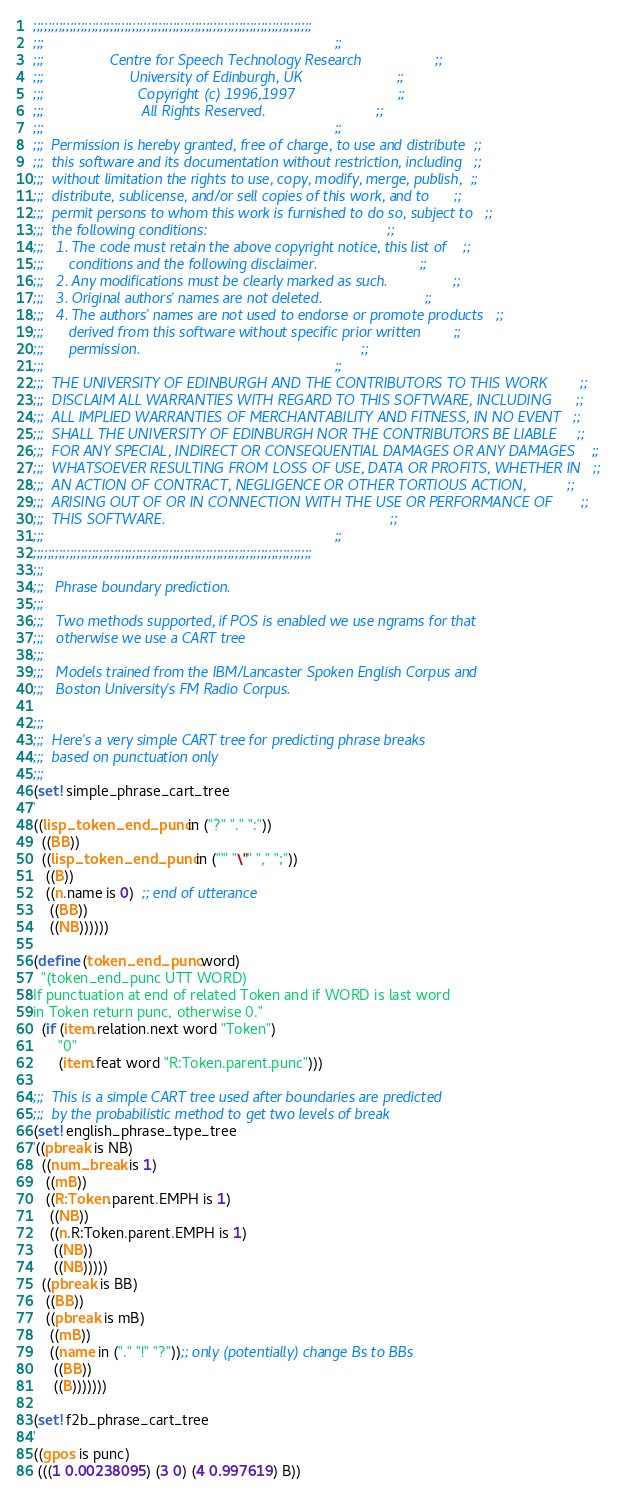<code> <loc_0><loc_0><loc_500><loc_500><_Scheme_>;;;;;;;;;;;;;;;;;;;;;;;;;;;;;;;;;;;;;;;;;;;;;;;;;;;;;;;;;;;;;;;;;;;;;;;;;;;;
;;;                                                                       ;;
;;;                Centre for Speech Technology Research                  ;;
;;;                     University of Edinburgh, UK                       ;;
;;;                       Copyright (c) 1996,1997                         ;;
;;;                        All Rights Reserved.                           ;;
;;;                                                                       ;;
;;;  Permission is hereby granted, free of charge, to use and distribute  ;;
;;;  this software and its documentation without restriction, including   ;;
;;;  without limitation the rights to use, copy, modify, merge, publish,  ;;
;;;  distribute, sublicense, and/or sell copies of this work, and to      ;;
;;;  permit persons to whom this work is furnished to do so, subject to   ;;
;;;  the following conditions:                                            ;;
;;;   1. The code must retain the above copyright notice, this list of    ;;
;;;      conditions and the following disclaimer.                         ;;
;;;   2. Any modifications must be clearly marked as such.                ;;
;;;   3. Original authors' names are not deleted.                         ;;
;;;   4. The authors' names are not used to endorse or promote products   ;;
;;;      derived from this software without specific prior written        ;;
;;;      permission.                                                      ;;
;;;                                                                       ;;
;;;  THE UNIVERSITY OF EDINBURGH AND THE CONTRIBUTORS TO THIS WORK        ;;
;;;  DISCLAIM ALL WARRANTIES WITH REGARD TO THIS SOFTWARE, INCLUDING      ;;
;;;  ALL IMPLIED WARRANTIES OF MERCHANTABILITY AND FITNESS, IN NO EVENT   ;;
;;;  SHALL THE UNIVERSITY OF EDINBURGH NOR THE CONTRIBUTORS BE LIABLE     ;;
;;;  FOR ANY SPECIAL, INDIRECT OR CONSEQUENTIAL DAMAGES OR ANY DAMAGES    ;;
;;;  WHATSOEVER RESULTING FROM LOSS OF USE, DATA OR PROFITS, WHETHER IN   ;;
;;;  AN ACTION OF CONTRACT, NEGLIGENCE OR OTHER TORTIOUS ACTION,          ;;
;;;  ARISING OUT OF OR IN CONNECTION WITH THE USE OR PERFORMANCE OF       ;;
;;;  THIS SOFTWARE.                                                       ;;
;;;                                                                       ;;
;;;;;;;;;;;;;;;;;;;;;;;;;;;;;;;;;;;;;;;;;;;;;;;;;;;;;;;;;;;;;;;;;;;;;;;;;;;;
;;;
;;;   Phrase boundary prediction.
;;;   
;;;   Two methods supported, if POS is enabled we use ngrams for that
;;;   otherwise we use a CART tree
;;;
;;;   Models trained from the IBM/Lancaster Spoken English Corpus and 
;;;   Boston University's FM Radio Corpus.

;;;
;;;  Here's a very simple CART tree for predicting phrase breaks
;;;  based on punctuation only
;;;
(set! simple_phrase_cart_tree
'
((lisp_token_end_punc in ("?" "." ":"))
  ((BB))
  ((lisp_token_end_punc in ("'" "\"" "," ";"))
   ((B))
   ((n.name is 0)  ;; end of utterance
    ((BB))
    ((NB))))))

(define (token_end_punc word)
  "(token_end_punc UTT WORD)
If punctuation at end of related Token and if WORD is last word
in Token return punc, otherwise 0."
  (if (item.relation.next word "Token")
      "0"
      (item.feat word "R:Token.parent.punc")))

;;;  This is a simple CART tree used after boundaries are predicted
;;;  by the probabilistic method to get two levels of break
(set! english_phrase_type_tree
'((pbreak is NB)
  ((num_break is 1)
   ((mB))
   ((R:Token.parent.EMPH is 1)
    ((NB))
    ((n.R:Token.parent.EMPH is 1)
     ((NB))
     ((NB)))))
  ((pbreak is BB)
   ((BB))
   ((pbreak is mB)
    ((mB))
    ((name in ("." "!" "?"));; only (potentially) change Bs to BBs
     ((BB))
     ((B)))))))

(set! f2b_phrase_cart_tree
'
((gpos is punc)
 (((1 0.00238095) (3 0) (4 0.997619) B))</code> 